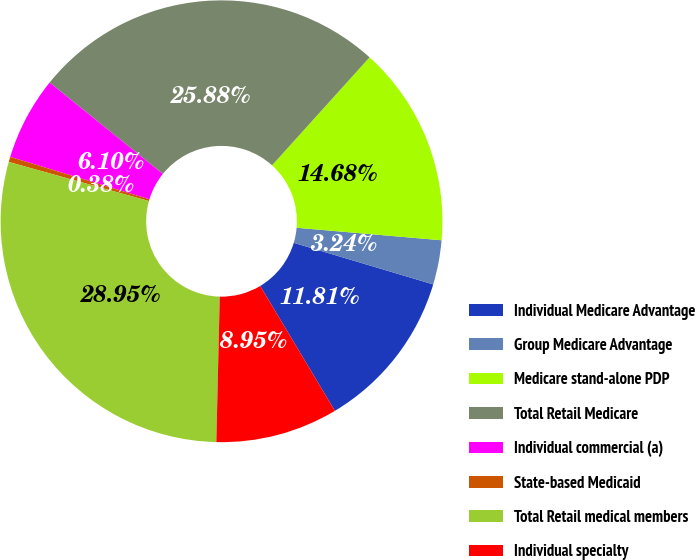Convert chart to OTSL. <chart><loc_0><loc_0><loc_500><loc_500><pie_chart><fcel>Individual Medicare Advantage<fcel>Group Medicare Advantage<fcel>Medicare stand-alone PDP<fcel>Total Retail Medicare<fcel>Individual commercial (a)<fcel>State-based Medicaid<fcel>Total Retail medical members<fcel>Individual specialty<nl><fcel>11.81%<fcel>3.24%<fcel>14.68%<fcel>25.88%<fcel>6.1%<fcel>0.38%<fcel>28.95%<fcel>8.95%<nl></chart> 